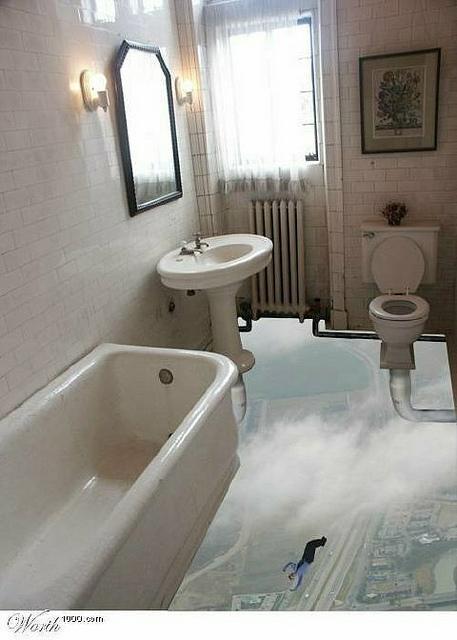How many pizzas are there?
Give a very brief answer. 0. 